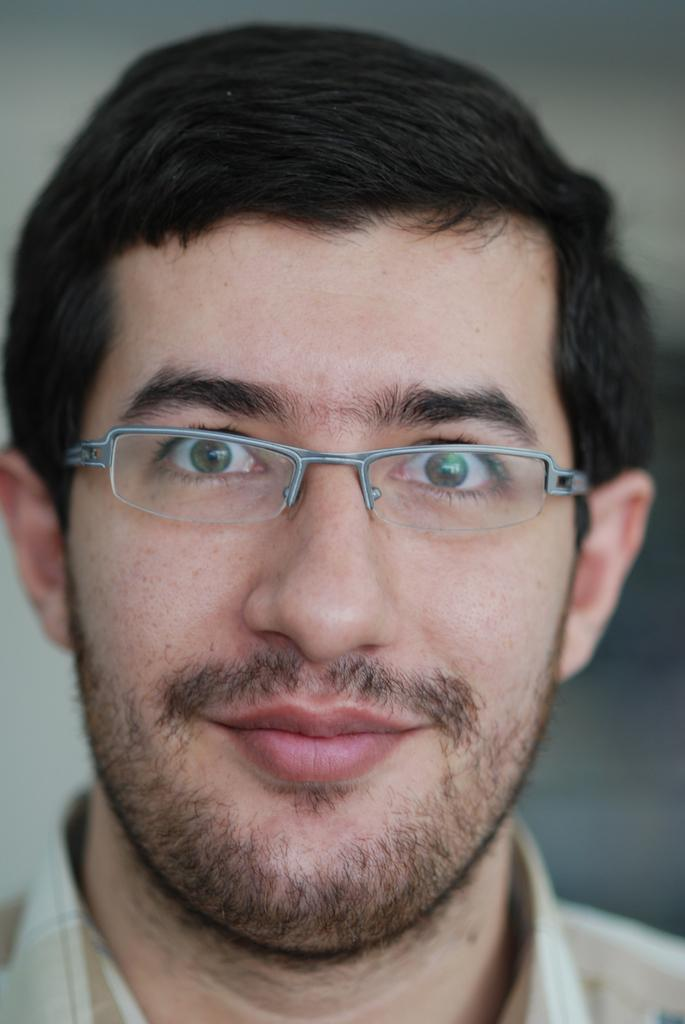Who is in the picture? There is a man in the picture. What can be observed about the man's appearance? The man is wearing glasses and has a small beard. What is the man's facial expression in the picture? The man is smiling. What is the purpose of the picture? The man is posing for a passport size photograph. Can you describe the background of the image? The background of the image is blurred. What type of road can be seen in the background of the image? There is no road visible in the background of the image; it is blurred. Are there any bears present in the image? There are no bears present in the image; it features a man posing for a passport size photograph. 